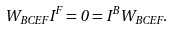Convert formula to latex. <formula><loc_0><loc_0><loc_500><loc_500>W _ { B C E F } I ^ { F } = 0 = I ^ { B } W _ { B C E F } .</formula> 